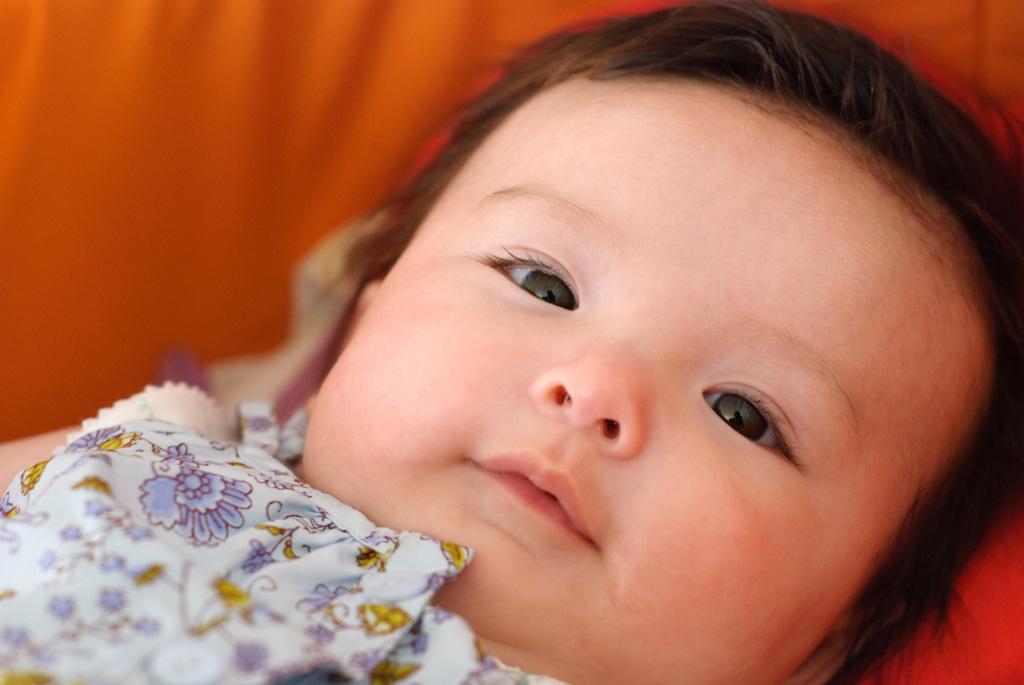Describe this image in one or two sentences. In the foreground of this image, there is a baby on an orange surface. 